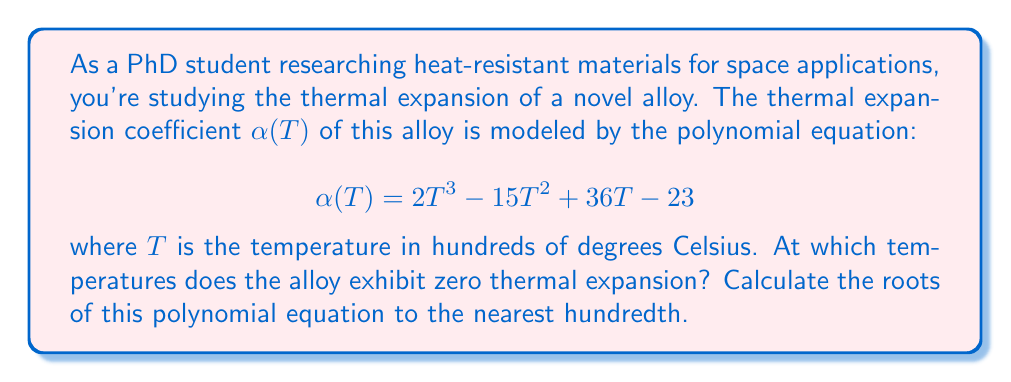Help me with this question. To find the temperatures at which the alloy exhibits zero thermal expansion, we need to solve the equation:

$$2T^3 - 15T^2 + 36T - 23 = 0$$

Let's solve this step-by-step:

1) First, we can factor out the greatest common factor:
   $$T(2T^2 - 15T + 36) - 23 = 0$$

2) This doesn't simplify further, so we'll need to use the cubic formula or a numerical method. Let's use the rational root theorem to check for any rational roots.

3) The possible rational roots are the factors of the constant term (23): ±1, ±23.

4) Testing these values, we find that T = 1 is a root.

5) We can now factor out (T - 1):
   $$(T - 1)(2T^2 - 13T + 23) = 0$$

6) The quadratic factor can be solved using the quadratic formula:
   $$T = \frac{13 \pm \sqrt{13^2 - 4(2)(23)}}{2(2)}$$

7) Simplifying:
   $$T = \frac{13 \pm \sqrt{169 - 184}}{4} = \frac{13 \pm \sqrt{-15}}{4}$$

8) This gives us two complex roots, which are not relevant for our physical problem.

9) Therefore, the only real root is T = 1.

10) Recall that T was in hundreds of degrees Celsius, so we need to multiply by 100 for the final answer.
Answer: 100°C 